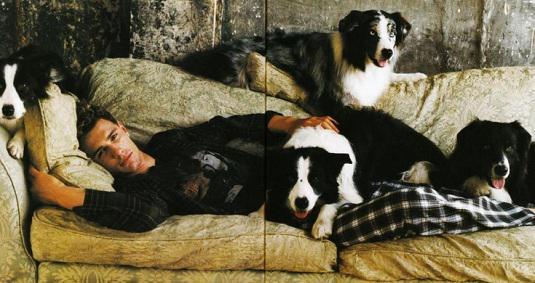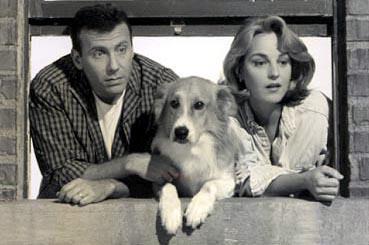The first image is the image on the left, the second image is the image on the right. Given the left and right images, does the statement "The right image contains only one human and one dog." hold true? Answer yes or no. No. The first image is the image on the left, the second image is the image on the right. Considering the images on both sides, is "An image shows a long-haired man in jeans crouching behind a black-and-white dog." valid? Answer yes or no. No. 